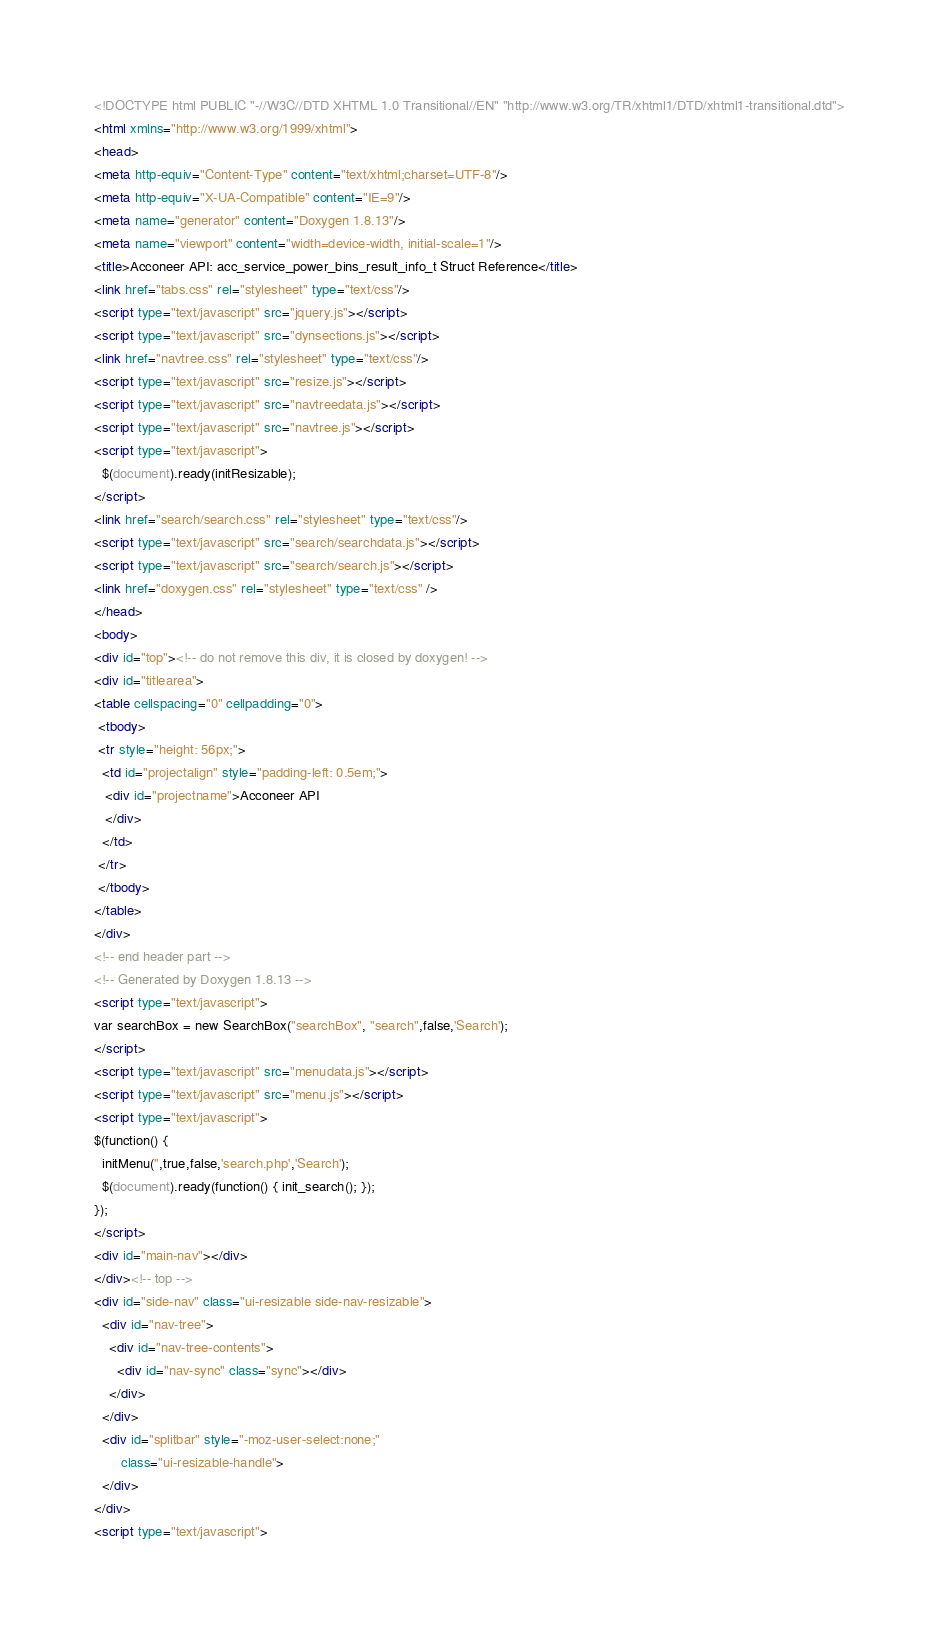<code> <loc_0><loc_0><loc_500><loc_500><_HTML_><!DOCTYPE html PUBLIC "-//W3C//DTD XHTML 1.0 Transitional//EN" "http://www.w3.org/TR/xhtml1/DTD/xhtml1-transitional.dtd">
<html xmlns="http://www.w3.org/1999/xhtml">
<head>
<meta http-equiv="Content-Type" content="text/xhtml;charset=UTF-8"/>
<meta http-equiv="X-UA-Compatible" content="IE=9"/>
<meta name="generator" content="Doxygen 1.8.13"/>
<meta name="viewport" content="width=device-width, initial-scale=1"/>
<title>Acconeer API: acc_service_power_bins_result_info_t Struct Reference</title>
<link href="tabs.css" rel="stylesheet" type="text/css"/>
<script type="text/javascript" src="jquery.js"></script>
<script type="text/javascript" src="dynsections.js"></script>
<link href="navtree.css" rel="stylesheet" type="text/css"/>
<script type="text/javascript" src="resize.js"></script>
<script type="text/javascript" src="navtreedata.js"></script>
<script type="text/javascript" src="navtree.js"></script>
<script type="text/javascript">
  $(document).ready(initResizable);
</script>
<link href="search/search.css" rel="stylesheet" type="text/css"/>
<script type="text/javascript" src="search/searchdata.js"></script>
<script type="text/javascript" src="search/search.js"></script>
<link href="doxygen.css" rel="stylesheet" type="text/css" />
</head>
<body>
<div id="top"><!-- do not remove this div, it is closed by doxygen! -->
<div id="titlearea">
<table cellspacing="0" cellpadding="0">
 <tbody>
 <tr style="height: 56px;">
  <td id="projectalign" style="padding-left: 0.5em;">
   <div id="projectname">Acconeer API
   </div>
  </td>
 </tr>
 </tbody>
</table>
</div>
<!-- end header part -->
<!-- Generated by Doxygen 1.8.13 -->
<script type="text/javascript">
var searchBox = new SearchBox("searchBox", "search",false,'Search');
</script>
<script type="text/javascript" src="menudata.js"></script>
<script type="text/javascript" src="menu.js"></script>
<script type="text/javascript">
$(function() {
  initMenu('',true,false,'search.php','Search');
  $(document).ready(function() { init_search(); });
});
</script>
<div id="main-nav"></div>
</div><!-- top -->
<div id="side-nav" class="ui-resizable side-nav-resizable">
  <div id="nav-tree">
    <div id="nav-tree-contents">
      <div id="nav-sync" class="sync"></div>
    </div>
  </div>
  <div id="splitbar" style="-moz-user-select:none;" 
       class="ui-resizable-handle">
  </div>
</div>
<script type="text/javascript"></code> 